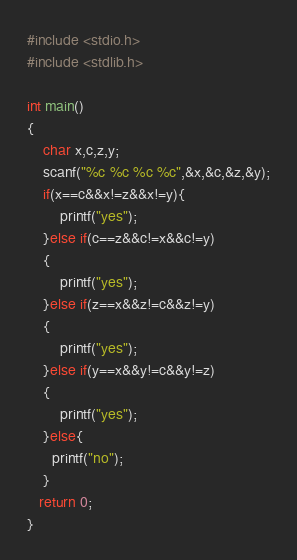<code> <loc_0><loc_0><loc_500><loc_500><_C_>#include <stdio.h>
#include <stdlib.h>

int main()
{
    char x,c,z,y;
    scanf("%c %c %c %c",&x,&c,&z,&y);
    if(x==c&&x!=z&&x!=y){
        printf("yes");
    }else if(c==z&&c!=x&&c!=y)
    {
        printf("yes");
    }else if(z==x&&z!=c&&z!=y)
    {
        printf("yes");
    }else if(y==x&&y!=c&&y!=z)
    {
        printf("yes");
    }else{
      printf("no");
    }
   return 0;
}</code> 